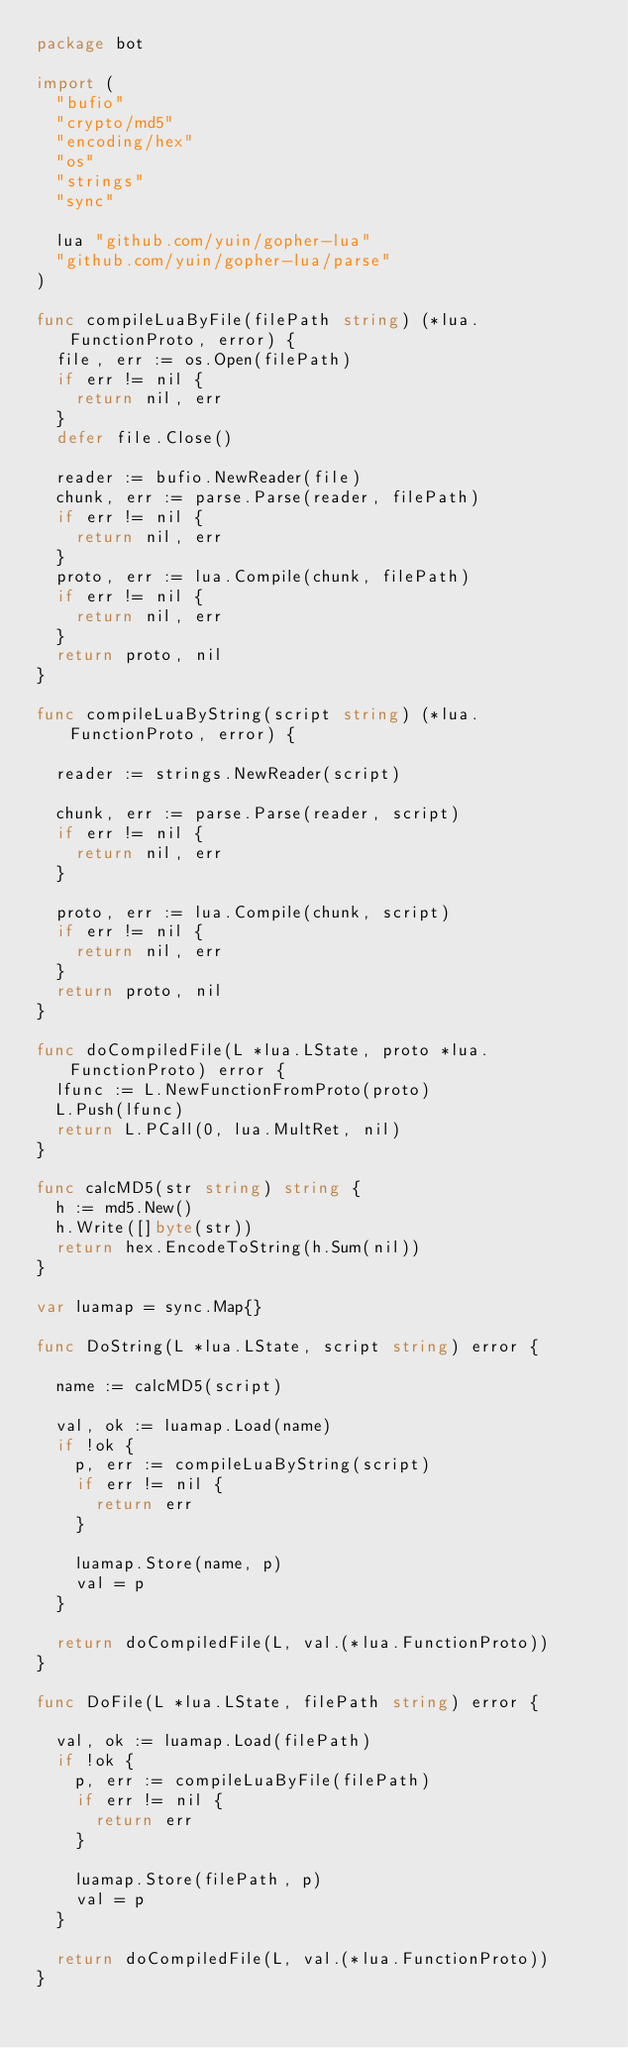Convert code to text. <code><loc_0><loc_0><loc_500><loc_500><_Go_>package bot

import (
	"bufio"
	"crypto/md5"
	"encoding/hex"
	"os"
	"strings"
	"sync"

	lua "github.com/yuin/gopher-lua"
	"github.com/yuin/gopher-lua/parse"
)

func compileLuaByFile(filePath string) (*lua.FunctionProto, error) {
	file, err := os.Open(filePath)
	if err != nil {
		return nil, err
	}
	defer file.Close()

	reader := bufio.NewReader(file)
	chunk, err := parse.Parse(reader, filePath)
	if err != nil {
		return nil, err
	}
	proto, err := lua.Compile(chunk, filePath)
	if err != nil {
		return nil, err
	}
	return proto, nil
}

func compileLuaByString(script string) (*lua.FunctionProto, error) {

	reader := strings.NewReader(script)

	chunk, err := parse.Parse(reader, script)
	if err != nil {
		return nil, err
	}

	proto, err := lua.Compile(chunk, script)
	if err != nil {
		return nil, err
	}
	return proto, nil
}

func doCompiledFile(L *lua.LState, proto *lua.FunctionProto) error {
	lfunc := L.NewFunctionFromProto(proto)
	L.Push(lfunc)
	return L.PCall(0, lua.MultRet, nil)
}

func calcMD5(str string) string {
	h := md5.New()
	h.Write([]byte(str))
	return hex.EncodeToString(h.Sum(nil))
}

var luamap = sync.Map{}

func DoString(L *lua.LState, script string) error {

	name := calcMD5(script)

	val, ok := luamap.Load(name)
	if !ok {
		p, err := compileLuaByString(script)
		if err != nil {
			return err
		}

		luamap.Store(name, p)
		val = p
	}

	return doCompiledFile(L, val.(*lua.FunctionProto))
}

func DoFile(L *lua.LState, filePath string) error {

	val, ok := luamap.Load(filePath)
	if !ok {
		p, err := compileLuaByFile(filePath)
		if err != nil {
			return err
		}

		luamap.Store(filePath, p)
		val = p
	}

	return doCompiledFile(L, val.(*lua.FunctionProto))
}
</code> 